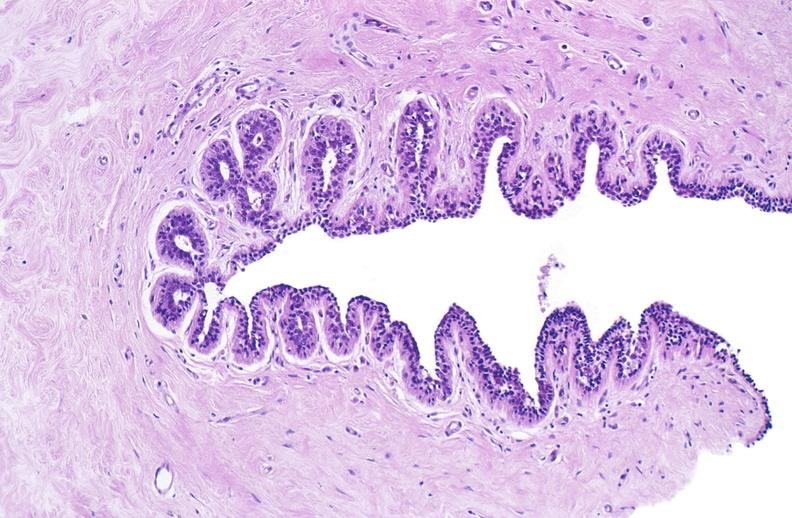does this image show normal breast?
Answer the question using a single word or phrase. Yes 